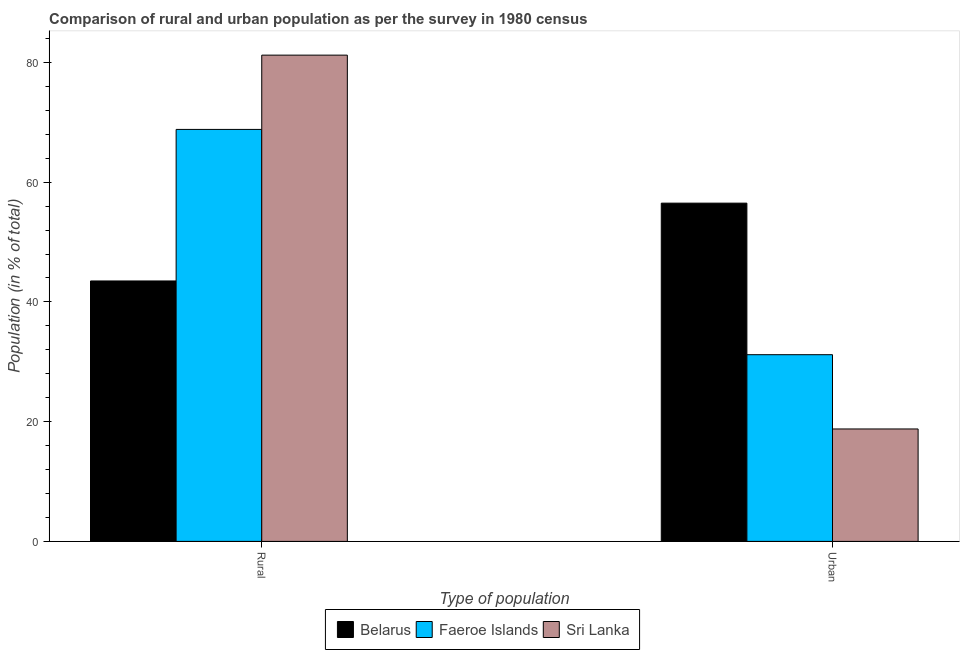How many groups of bars are there?
Ensure brevity in your answer.  2. Are the number of bars on each tick of the X-axis equal?
Your answer should be compact. Yes. How many bars are there on the 2nd tick from the left?
Provide a short and direct response. 3. What is the label of the 2nd group of bars from the left?
Offer a terse response. Urban. What is the urban population in Faeroe Islands?
Offer a terse response. 31.19. Across all countries, what is the maximum urban population?
Ensure brevity in your answer.  56.5. Across all countries, what is the minimum urban population?
Offer a very short reply. 18.78. In which country was the urban population maximum?
Your answer should be very brief. Belarus. In which country was the urban population minimum?
Provide a succinct answer. Sri Lanka. What is the total rural population in the graph?
Provide a short and direct response. 193.54. What is the difference between the rural population in Sri Lanka and that in Belarus?
Your answer should be compact. 37.72. What is the difference between the urban population in Belarus and the rural population in Sri Lanka?
Provide a short and direct response. -24.72. What is the average urban population per country?
Give a very brief answer. 35.49. What is the difference between the rural population and urban population in Sri Lanka?
Offer a very short reply. 62.44. What is the ratio of the rural population in Sri Lanka to that in Faeroe Islands?
Your response must be concise. 1.18. Is the rural population in Belarus less than that in Sri Lanka?
Your answer should be compact. Yes. In how many countries, is the rural population greater than the average rural population taken over all countries?
Give a very brief answer. 2. What does the 1st bar from the left in Urban represents?
Your response must be concise. Belarus. What does the 2nd bar from the right in Rural represents?
Your answer should be very brief. Faeroe Islands. Are the values on the major ticks of Y-axis written in scientific E-notation?
Ensure brevity in your answer.  No. Does the graph contain grids?
Provide a succinct answer. No. Where does the legend appear in the graph?
Keep it short and to the point. Bottom center. How many legend labels are there?
Provide a short and direct response. 3. What is the title of the graph?
Your answer should be compact. Comparison of rural and urban population as per the survey in 1980 census. Does "Seychelles" appear as one of the legend labels in the graph?
Your response must be concise. No. What is the label or title of the X-axis?
Ensure brevity in your answer.  Type of population. What is the label or title of the Y-axis?
Make the answer very short. Population (in % of total). What is the Population (in % of total) in Belarus in Rural?
Keep it short and to the point. 43.5. What is the Population (in % of total) in Faeroe Islands in Rural?
Your response must be concise. 68.81. What is the Population (in % of total) of Sri Lanka in Rural?
Offer a terse response. 81.22. What is the Population (in % of total) in Belarus in Urban?
Provide a succinct answer. 56.5. What is the Population (in % of total) of Faeroe Islands in Urban?
Offer a very short reply. 31.19. What is the Population (in % of total) of Sri Lanka in Urban?
Your answer should be compact. 18.78. Across all Type of population, what is the maximum Population (in % of total) in Belarus?
Offer a very short reply. 56.5. Across all Type of population, what is the maximum Population (in % of total) of Faeroe Islands?
Provide a succinct answer. 68.81. Across all Type of population, what is the maximum Population (in % of total) in Sri Lanka?
Provide a succinct answer. 81.22. Across all Type of population, what is the minimum Population (in % of total) in Belarus?
Make the answer very short. 43.5. Across all Type of population, what is the minimum Population (in % of total) of Faeroe Islands?
Provide a succinct answer. 31.19. Across all Type of population, what is the minimum Population (in % of total) of Sri Lanka?
Your response must be concise. 18.78. What is the difference between the Population (in % of total) of Belarus in Rural and that in Urban?
Offer a terse response. -13. What is the difference between the Population (in % of total) of Faeroe Islands in Rural and that in Urban?
Provide a succinct answer. 37.63. What is the difference between the Population (in % of total) of Sri Lanka in Rural and that in Urban?
Give a very brief answer. 62.44. What is the difference between the Population (in % of total) of Belarus in Rural and the Population (in % of total) of Faeroe Islands in Urban?
Offer a very short reply. 12.32. What is the difference between the Population (in % of total) in Belarus in Rural and the Population (in % of total) in Sri Lanka in Urban?
Offer a terse response. 24.72. What is the difference between the Population (in % of total) in Faeroe Islands in Rural and the Population (in % of total) in Sri Lanka in Urban?
Provide a short and direct response. 50.03. What is the average Population (in % of total) in Belarus per Type of population?
Offer a terse response. 50. What is the average Population (in % of total) of Faeroe Islands per Type of population?
Give a very brief answer. 50. What is the average Population (in % of total) in Sri Lanka per Type of population?
Offer a terse response. 50. What is the difference between the Population (in % of total) in Belarus and Population (in % of total) in Faeroe Islands in Rural?
Your answer should be very brief. -25.31. What is the difference between the Population (in % of total) in Belarus and Population (in % of total) in Sri Lanka in Rural?
Your answer should be very brief. -37.72. What is the difference between the Population (in % of total) of Faeroe Islands and Population (in % of total) of Sri Lanka in Rural?
Your answer should be compact. -12.41. What is the difference between the Population (in % of total) in Belarus and Population (in % of total) in Faeroe Islands in Urban?
Offer a terse response. 25.31. What is the difference between the Population (in % of total) of Belarus and Population (in % of total) of Sri Lanka in Urban?
Keep it short and to the point. 37.72. What is the difference between the Population (in % of total) of Faeroe Islands and Population (in % of total) of Sri Lanka in Urban?
Ensure brevity in your answer.  12.41. What is the ratio of the Population (in % of total) in Belarus in Rural to that in Urban?
Your response must be concise. 0.77. What is the ratio of the Population (in % of total) of Faeroe Islands in Rural to that in Urban?
Provide a succinct answer. 2.21. What is the ratio of the Population (in % of total) in Sri Lanka in Rural to that in Urban?
Your response must be concise. 4.33. What is the difference between the highest and the second highest Population (in % of total) of Belarus?
Offer a very short reply. 13. What is the difference between the highest and the second highest Population (in % of total) in Faeroe Islands?
Your answer should be very brief. 37.63. What is the difference between the highest and the second highest Population (in % of total) of Sri Lanka?
Offer a terse response. 62.44. What is the difference between the highest and the lowest Population (in % of total) in Belarus?
Make the answer very short. 13. What is the difference between the highest and the lowest Population (in % of total) of Faeroe Islands?
Provide a short and direct response. 37.63. What is the difference between the highest and the lowest Population (in % of total) of Sri Lanka?
Keep it short and to the point. 62.44. 